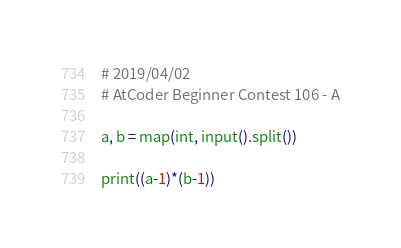<code> <loc_0><loc_0><loc_500><loc_500><_Python_># 2019/04/02
# AtCoder Beginner Contest 106 - A

a, b = map(int, input().split())

print((a-1)*(b-1))
</code> 